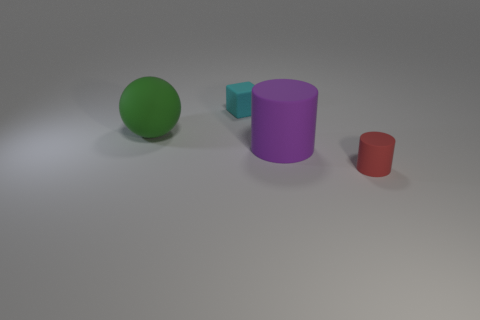Add 3 blue rubber blocks. How many objects exist? 7 Subtract all cubes. How many objects are left? 3 Subtract all red cylinders. How many cylinders are left? 1 Subtract all gray shiny balls. Subtract all tiny things. How many objects are left? 2 Add 2 tiny cylinders. How many tiny cylinders are left? 3 Add 1 small green matte cubes. How many small green matte cubes exist? 1 Subtract 1 green balls. How many objects are left? 3 Subtract 1 balls. How many balls are left? 0 Subtract all gray cubes. Subtract all green spheres. How many cubes are left? 1 